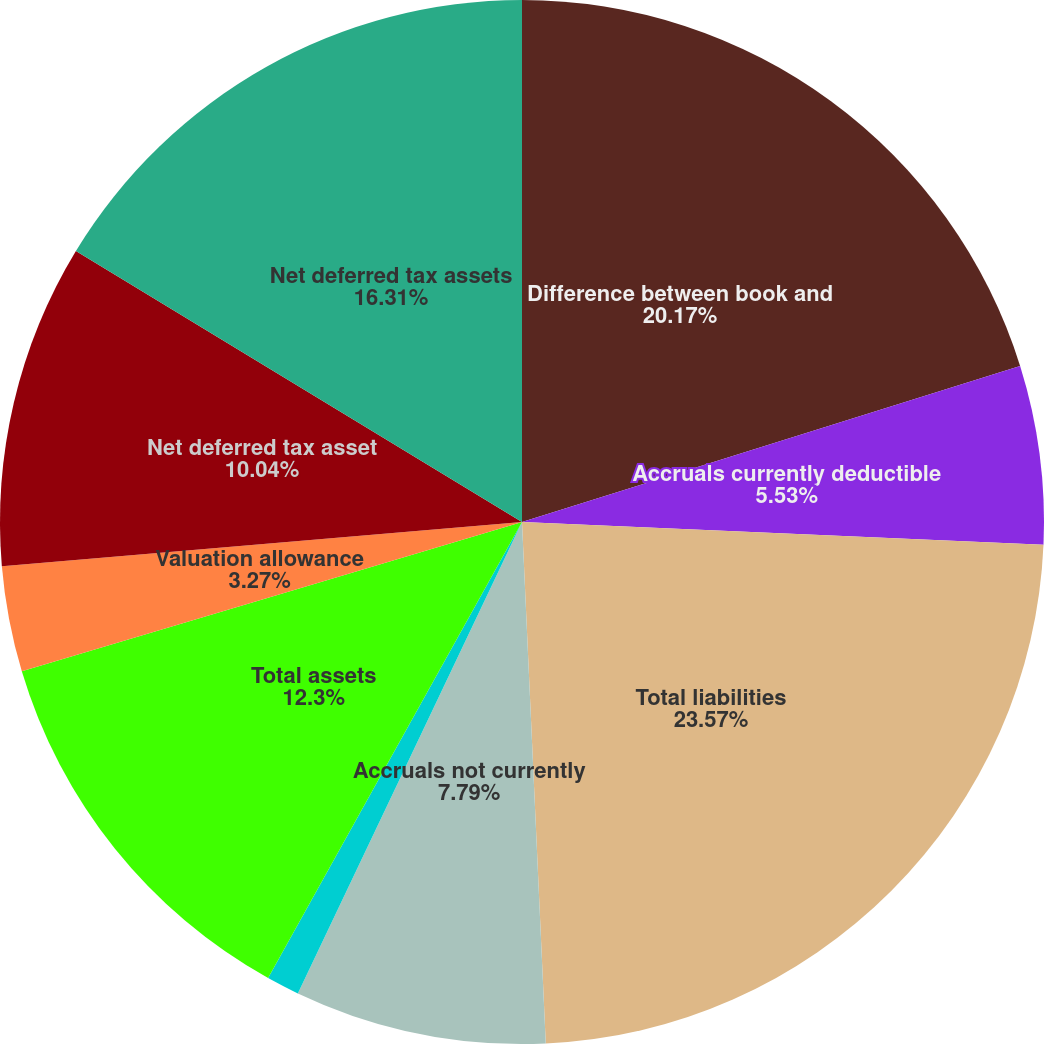Convert chart to OTSL. <chart><loc_0><loc_0><loc_500><loc_500><pie_chart><fcel>Difference between book and<fcel>Accruals currently deductible<fcel>Total liabilities<fcel>Accruals not currently<fcel>Net operating loss<fcel>Total assets<fcel>Valuation allowance<fcel>Net deferred tax asset<fcel>Net deferred tax assets<nl><fcel>20.17%<fcel>5.53%<fcel>23.58%<fcel>7.79%<fcel>1.02%<fcel>12.3%<fcel>3.27%<fcel>10.04%<fcel>16.31%<nl></chart> 